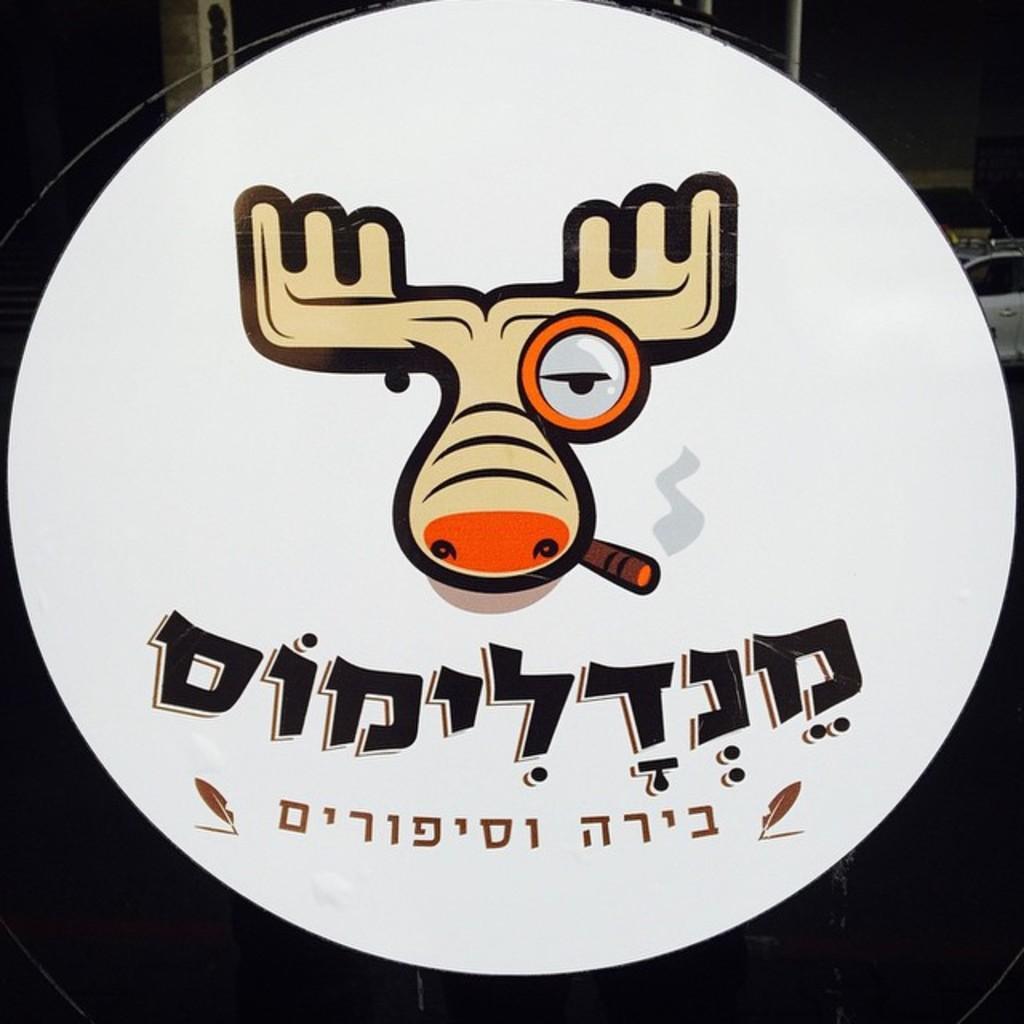Describe this image in one or two sentences. In this picture there is a poster with the symbol of an animal and there is some text written on the poster. In the background there is a car which is white in colour is visible. 